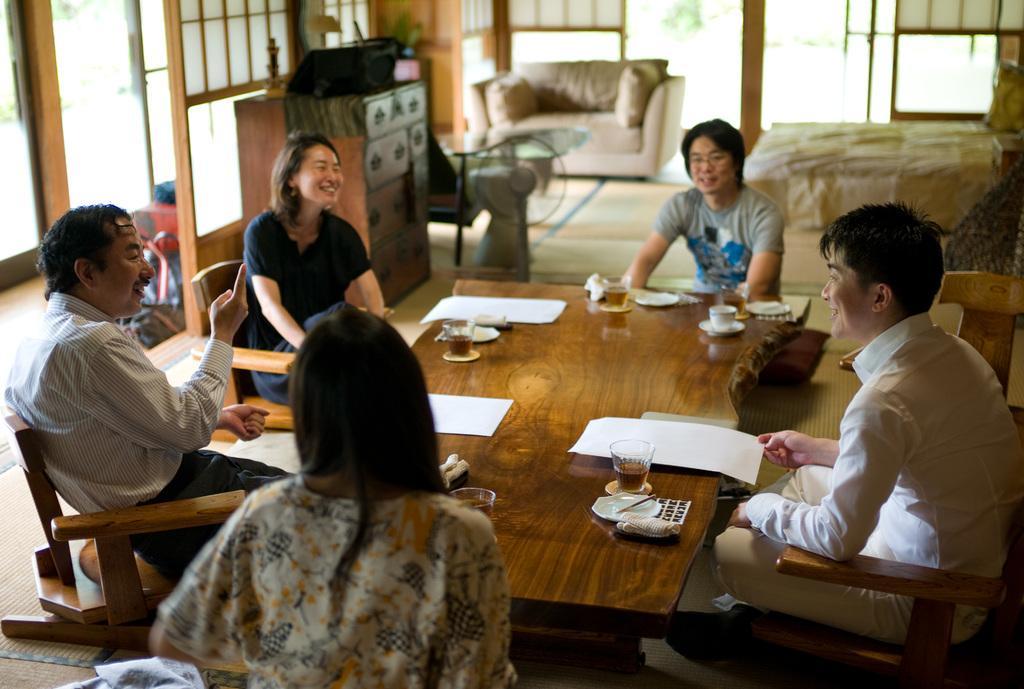Please provide a concise description of this image. This is a picture of a living room where there is a cupboard consisting of drawers ,a table fan , a couch with 2 pillows, a bed with a white blanket , a table with some papers, cup,saucer, chopstick,chair , a man , another man , woman ,another man , a woman , sitting in the chairs. 